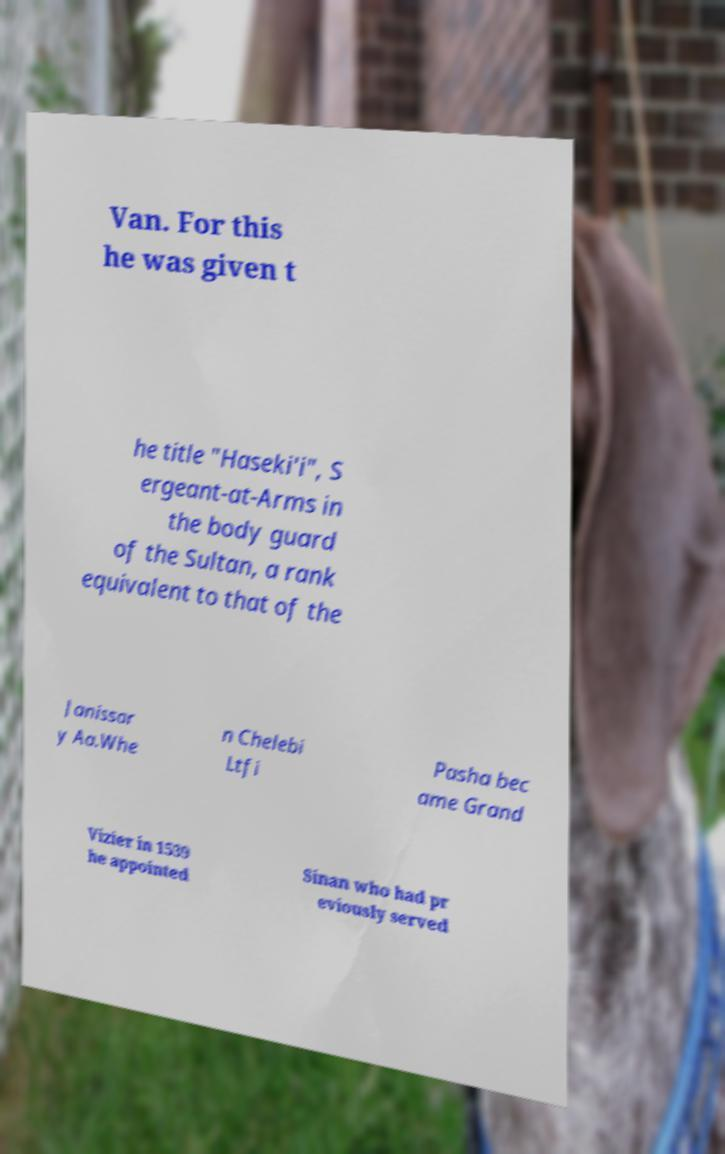I need the written content from this picture converted into text. Can you do that? Van. For this he was given t he title "Haseki'i", S ergeant-at-Arms in the body guard of the Sultan, a rank equivalent to that of the Janissar y Aa.Whe n Chelebi Ltfi Pasha bec ame Grand Vizier in 1539 he appointed Sinan who had pr eviously served 